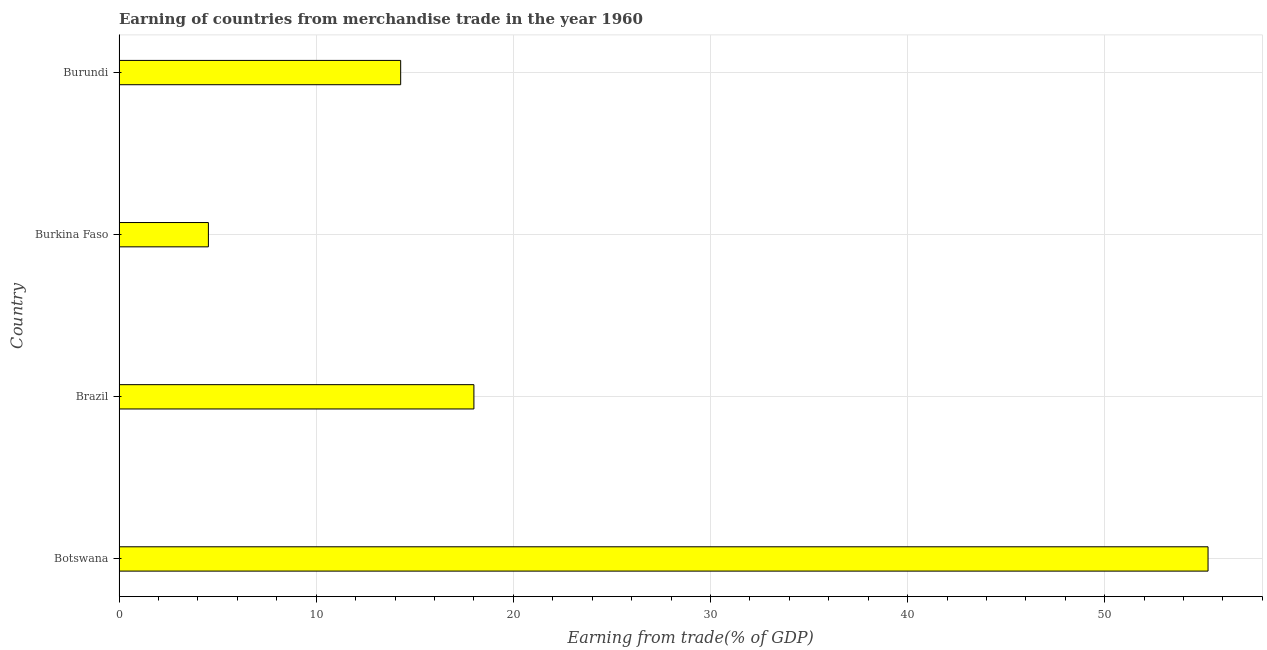Does the graph contain any zero values?
Provide a short and direct response. No. What is the title of the graph?
Give a very brief answer. Earning of countries from merchandise trade in the year 1960. What is the label or title of the X-axis?
Keep it short and to the point. Earning from trade(% of GDP). What is the earning from merchandise trade in Botswana?
Provide a short and direct response. 55.24. Across all countries, what is the maximum earning from merchandise trade?
Offer a very short reply. 55.24. Across all countries, what is the minimum earning from merchandise trade?
Provide a short and direct response. 4.53. In which country was the earning from merchandise trade maximum?
Your answer should be compact. Botswana. In which country was the earning from merchandise trade minimum?
Provide a short and direct response. Burkina Faso. What is the sum of the earning from merchandise trade?
Provide a succinct answer. 92.06. What is the difference between the earning from merchandise trade in Botswana and Burundi?
Your answer should be very brief. 40.96. What is the average earning from merchandise trade per country?
Make the answer very short. 23.02. What is the median earning from merchandise trade?
Keep it short and to the point. 16.14. What is the ratio of the earning from merchandise trade in Burkina Faso to that in Burundi?
Offer a terse response. 0.32. What is the difference between the highest and the second highest earning from merchandise trade?
Provide a short and direct response. 37.24. What is the difference between the highest and the lowest earning from merchandise trade?
Your answer should be very brief. 50.71. In how many countries, is the earning from merchandise trade greater than the average earning from merchandise trade taken over all countries?
Give a very brief answer. 1. What is the difference between two consecutive major ticks on the X-axis?
Your answer should be very brief. 10. What is the Earning from trade(% of GDP) of Botswana?
Ensure brevity in your answer.  55.24. What is the Earning from trade(% of GDP) in Brazil?
Offer a terse response. 18. What is the Earning from trade(% of GDP) of Burkina Faso?
Your answer should be compact. 4.53. What is the Earning from trade(% of GDP) of Burundi?
Make the answer very short. 14.29. What is the difference between the Earning from trade(% of GDP) in Botswana and Brazil?
Your response must be concise. 37.24. What is the difference between the Earning from trade(% of GDP) in Botswana and Burkina Faso?
Your response must be concise. 50.71. What is the difference between the Earning from trade(% of GDP) in Botswana and Burundi?
Give a very brief answer. 40.96. What is the difference between the Earning from trade(% of GDP) in Brazil and Burkina Faso?
Give a very brief answer. 13.47. What is the difference between the Earning from trade(% of GDP) in Brazil and Burundi?
Offer a terse response. 3.72. What is the difference between the Earning from trade(% of GDP) in Burkina Faso and Burundi?
Give a very brief answer. -9.75. What is the ratio of the Earning from trade(% of GDP) in Botswana to that in Brazil?
Offer a very short reply. 3.07. What is the ratio of the Earning from trade(% of GDP) in Botswana to that in Burkina Faso?
Make the answer very short. 12.19. What is the ratio of the Earning from trade(% of GDP) in Botswana to that in Burundi?
Offer a very short reply. 3.87. What is the ratio of the Earning from trade(% of GDP) in Brazil to that in Burkina Faso?
Your answer should be compact. 3.97. What is the ratio of the Earning from trade(% of GDP) in Brazil to that in Burundi?
Make the answer very short. 1.26. What is the ratio of the Earning from trade(% of GDP) in Burkina Faso to that in Burundi?
Your answer should be very brief. 0.32. 